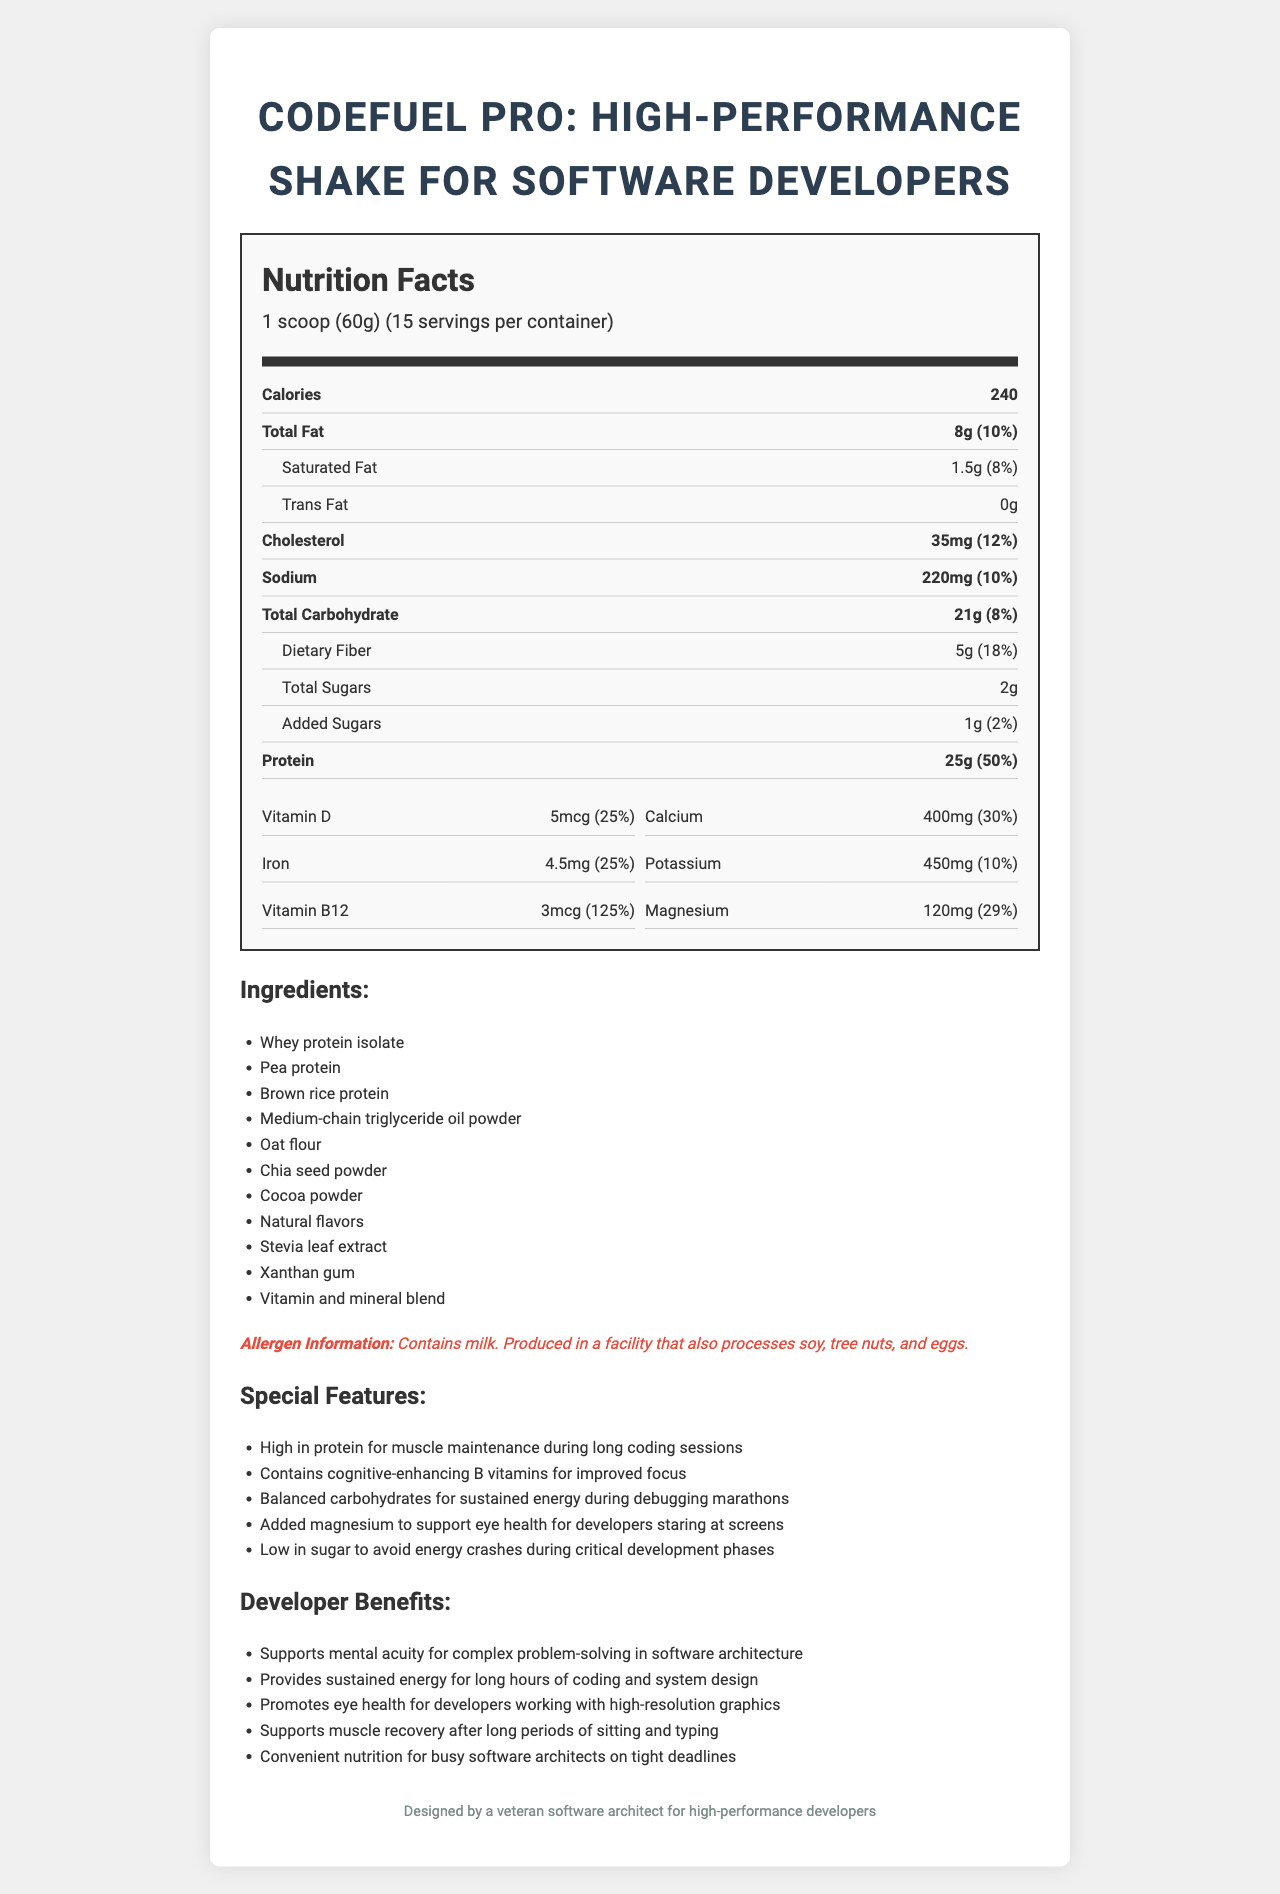what is the serving size? The serving size is explicitly stated as "1 scoop (60g)" in the serving information section.
Answer: 1 scoop (60g) how many servings are there per container? The document mentions "15 servings per container."
Answer: 15 how many calories are in one serving? The calorie content for one serving is specified as 240 calories.
Answer: 240 what is the total fat content per serving? The total fat content per serving is listed as 8 grams.
Answer: 8g how much protein does each serving provide? The protein content per serving is clearly noted as 25 grams.
Answer: 25g what are the special features of this shake? (A. High in protein, B. Contains cognitive-enhancing B vitamins, C. Low in sugar, D. All of the above) The special features section lists these attributes: high in protein, contains cognitive-enhancing B vitamins, and low in sugar.
Answer: D. All of the above which vitamin has the highest percent daily value? (A: Vitamin D, B: Calcium, C: Vitamin B12, D: Iron) Vitamin B12 has a percent daily value of 125%, which is the highest listed.
Answer: C: Vitamin B12 is this product suitable for someone with a soy allergy? The product is produced in a facility that also processes soy, as mentioned in the allergen information.
Answer: No how much dietary fiber is available per serving? The dietary fiber per serving is listed as 5 grams.
Answer: 5g what is the main idea of the document? The document comprehensively covers nutritional facts, ingredients, allergen details, special features, and developer benefits, all tailored towards the needs of software developers.
Answer: The document provides detailed nutritional information, ingredients, allergen information, and special features of the "CodeFuel Pro: High-Performance Shake for Software Developers," emphasizing its benefits for busy software developers. How much calcium is provided per serving and what percentage of the daily value does it represent? Each serving provides 400mg of calcium, which is 30% of the daily value.
Answer: 400mg, 30% what are the cognitive benefits mentioned for developers? The document lists "Contains cognitive-enhancing B vitamins for improved focus" as one of the special features for developers.
Answer: Contains cognitive-enhancing B vitamins for improved focus what type of fat is entirely absent in the shake? The document lists the trans fat content as 0 grams.
Answer: Trans fat how much sodium does one serving contain? The sodium content per serving is 220 milligrams.
Answer: 220mg Is the source code used to generate the document written in Python? The question pertains to the coding details which are not visible in the visual information of the document.
Answer: Cannot be determined 